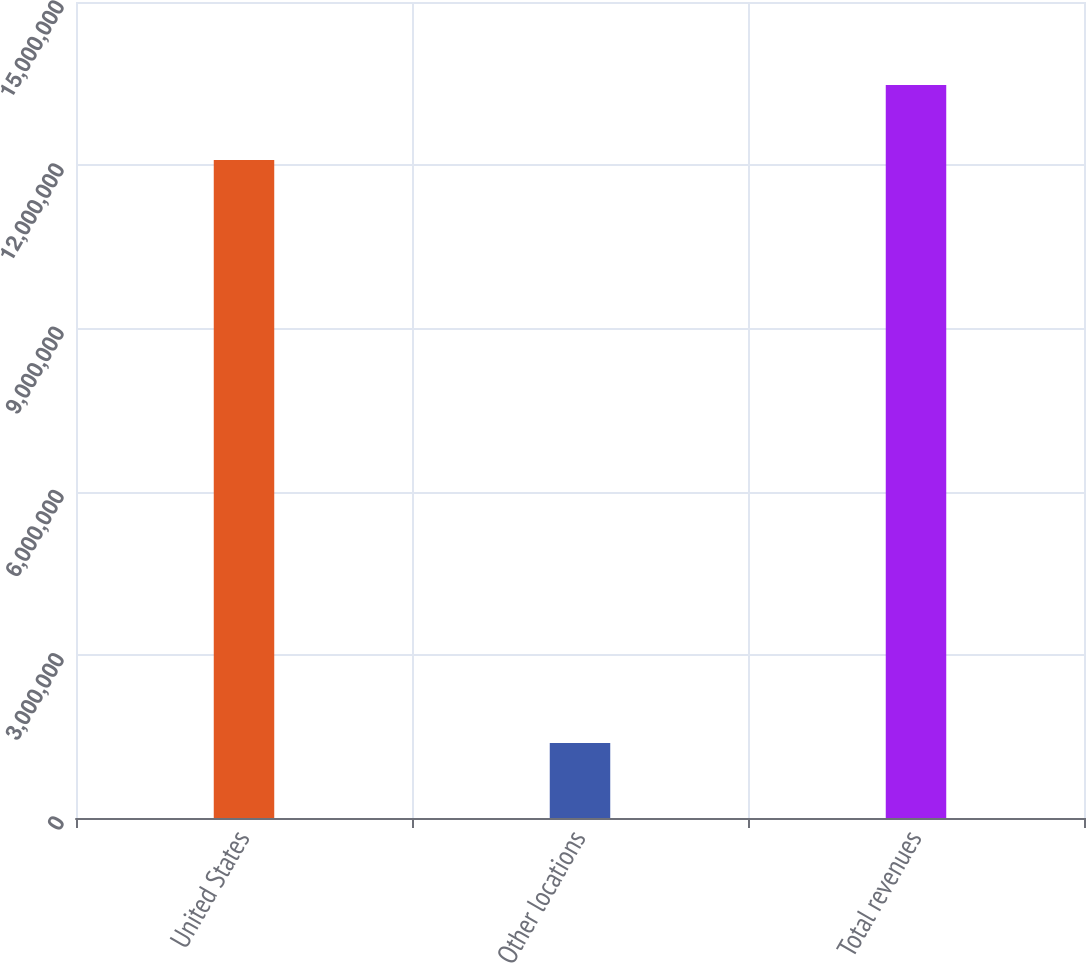Convert chart to OTSL. <chart><loc_0><loc_0><loc_500><loc_500><bar_chart><fcel>United States<fcel>Other locations<fcel>Total revenues<nl><fcel>1.20976e+07<fcel>1.37845e+06<fcel>1.34761e+07<nl></chart> 